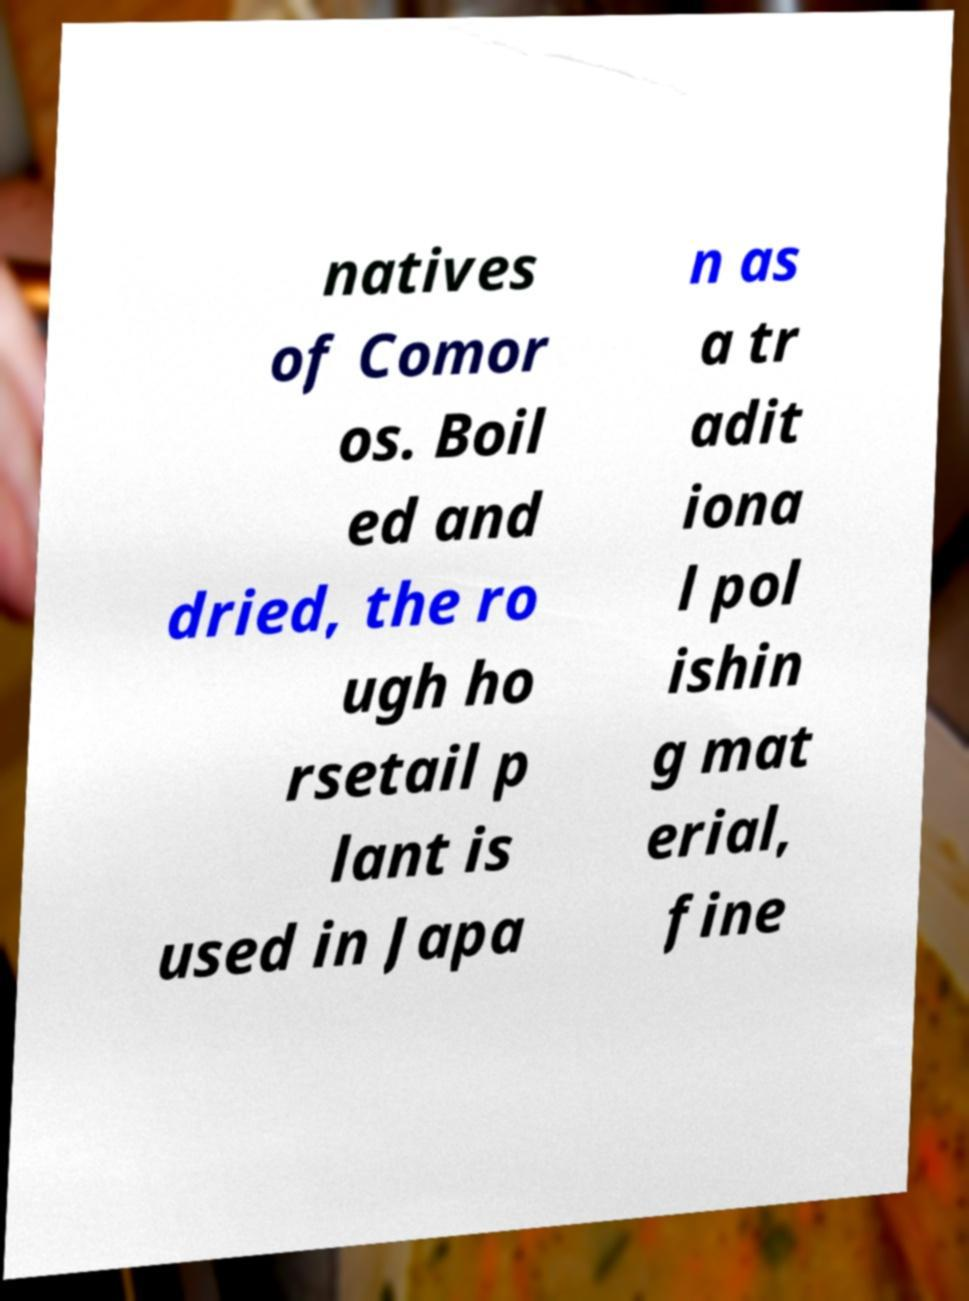There's text embedded in this image that I need extracted. Can you transcribe it verbatim? natives of Comor os. Boil ed and dried, the ro ugh ho rsetail p lant is used in Japa n as a tr adit iona l pol ishin g mat erial, fine 